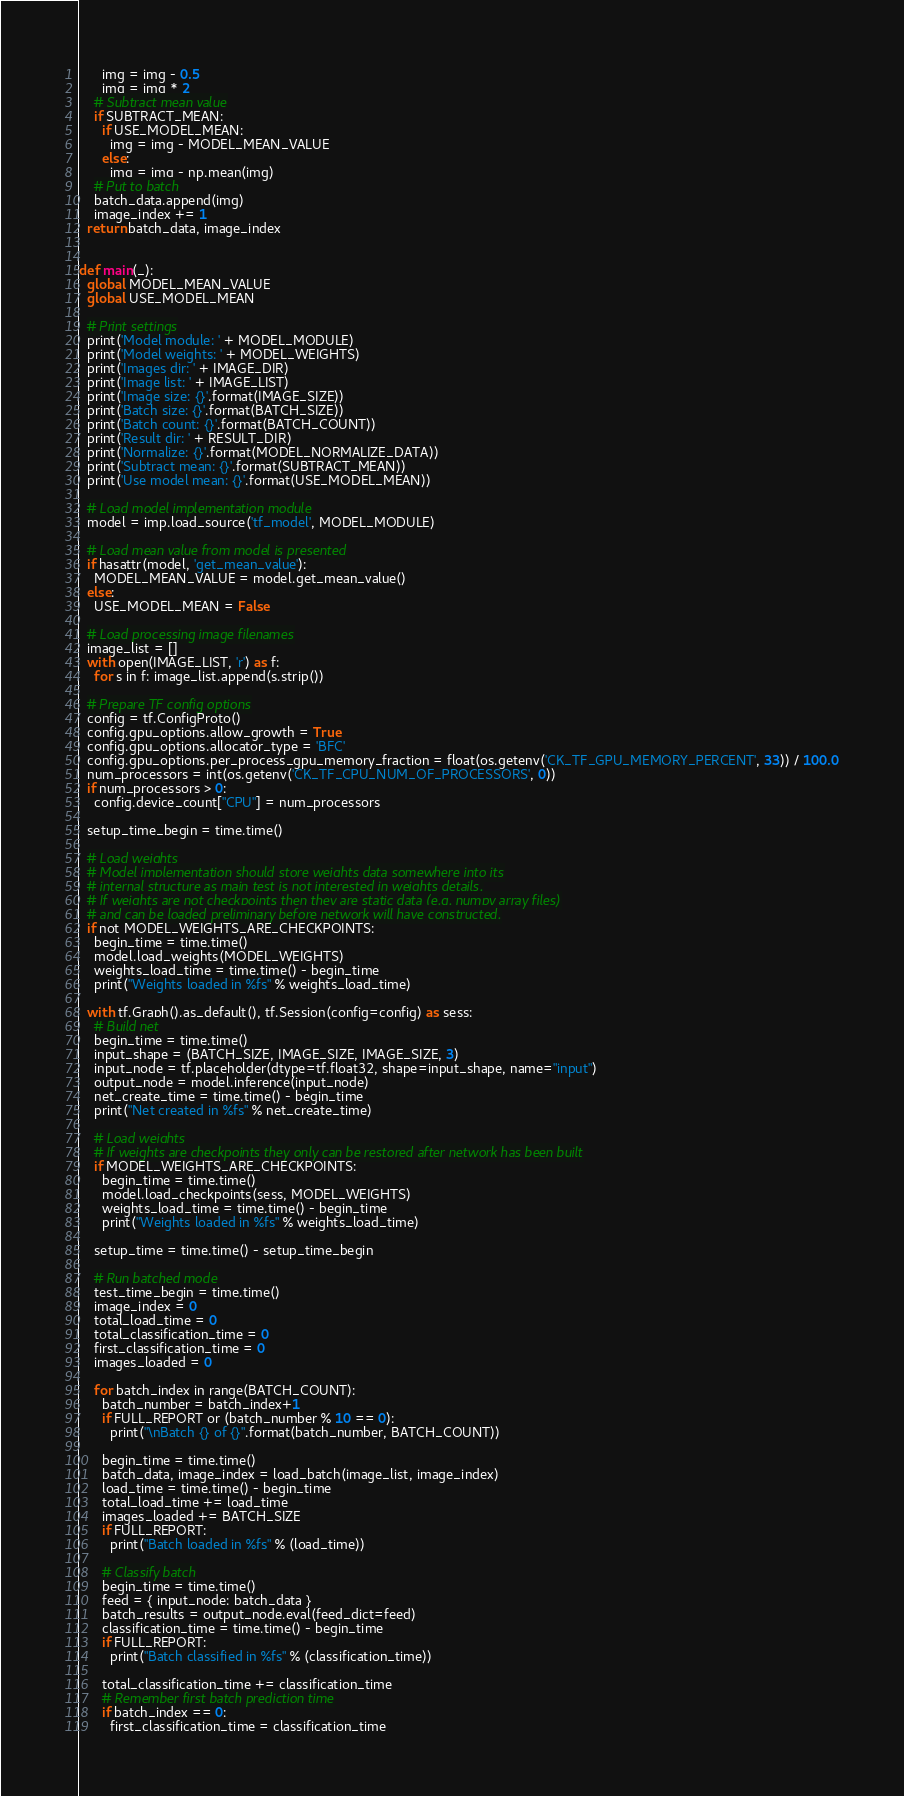<code> <loc_0><loc_0><loc_500><loc_500><_Python_>      img = img - 0.5
      img = img * 2
    # Subtract mean value
    if SUBTRACT_MEAN:
      if USE_MODEL_MEAN:
        img = img - MODEL_MEAN_VALUE
      else:
        img = img - np.mean(img)
    # Put to batch
    batch_data.append(img)
    image_index += 1
  return batch_data, image_index


def main(_):
  global MODEL_MEAN_VALUE
  global USE_MODEL_MEAN

  # Print settings
  print('Model module: ' + MODEL_MODULE)
  print('Model weights: ' + MODEL_WEIGHTS)
  print('Images dir: ' + IMAGE_DIR)
  print('Image list: ' + IMAGE_LIST)
  print('Image size: {}'.format(IMAGE_SIZE))
  print('Batch size: {}'.format(BATCH_SIZE))
  print('Batch count: {}'.format(BATCH_COUNT))
  print('Result dir: ' + RESULT_DIR)
  print('Normalize: {}'.format(MODEL_NORMALIZE_DATA))
  print('Subtract mean: {}'.format(SUBTRACT_MEAN))
  print('Use model mean: {}'.format(USE_MODEL_MEAN))

  # Load model implementation module
  model = imp.load_source('tf_model', MODEL_MODULE)

  # Load mean value from model is presented
  if hasattr(model, 'get_mean_value'):
    MODEL_MEAN_VALUE = model.get_mean_value()
  else:
    USE_MODEL_MEAN = False

  # Load processing image filenames
  image_list = []
  with open(IMAGE_LIST, 'r') as f:
    for s in f: image_list.append(s.strip())

  # Prepare TF config options
  config = tf.ConfigProto()
  config.gpu_options.allow_growth = True
  config.gpu_options.allocator_type = 'BFC'
  config.gpu_options.per_process_gpu_memory_fraction = float(os.getenv('CK_TF_GPU_MEMORY_PERCENT', 33)) / 100.0
  num_processors = int(os.getenv('CK_TF_CPU_NUM_OF_PROCESSORS', 0))
  if num_processors > 0:
    config.device_count["CPU"] = num_processors
    
  setup_time_begin = time.time()

  # Load weights
  # Model implementation should store weights data somewhere into its
  # internal structure as main test is not interested in weights details.
  # If weights are not checkpoints then they are static data (e.g. numpy array files)
  # and can be loaded preliminary before network will have constructed.
  if not MODEL_WEIGHTS_ARE_CHECKPOINTS:
    begin_time = time.time()
    model.load_weights(MODEL_WEIGHTS)
    weights_load_time = time.time() - begin_time
    print("Weights loaded in %fs" % weights_load_time)
    
  with tf.Graph().as_default(), tf.Session(config=config) as sess:
    # Build net
    begin_time = time.time()
    input_shape = (BATCH_SIZE, IMAGE_SIZE, IMAGE_SIZE, 3)
    input_node = tf.placeholder(dtype=tf.float32, shape=input_shape, name="input")
    output_node = model.inference(input_node)
    net_create_time = time.time() - begin_time
    print("Net created in %fs" % net_create_time)

    # Load weights
    # If weights are checkpoints they only can be restored after network has been built
    if MODEL_WEIGHTS_ARE_CHECKPOINTS:
      begin_time = time.time()
      model.load_checkpoints(sess, MODEL_WEIGHTS)
      weights_load_time = time.time() - begin_time
      print("Weights loaded in %fs" % weights_load_time)

    setup_time = time.time() - setup_time_begin

    # Run batched mode
    test_time_begin = time.time()
    image_index = 0
    total_load_time = 0
    total_classification_time = 0
    first_classification_time = 0
    images_loaded = 0

    for batch_index in range(BATCH_COUNT):
      batch_number = batch_index+1
      if FULL_REPORT or (batch_number % 10 == 0):
        print("\nBatch {} of {}".format(batch_number, BATCH_COUNT))
      
      begin_time = time.time()
      batch_data, image_index = load_batch(image_list, image_index)
      load_time = time.time() - begin_time
      total_load_time += load_time
      images_loaded += BATCH_SIZE
      if FULL_REPORT:
        print("Batch loaded in %fs" % (load_time))

      # Classify batch
      begin_time = time.time()
      feed = { input_node: batch_data }
      batch_results = output_node.eval(feed_dict=feed)
      classification_time = time.time() - begin_time
      if FULL_REPORT:
        print("Batch classified in %fs" % (classification_time))
      
      total_classification_time += classification_time
      # Remember first batch prediction time
      if batch_index == 0:
        first_classification_time = classification_time
</code> 